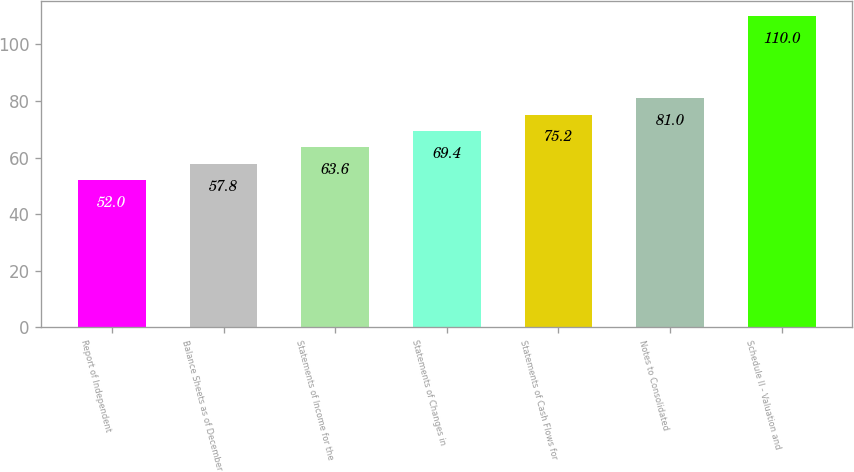<chart> <loc_0><loc_0><loc_500><loc_500><bar_chart><fcel>Report of Independent<fcel>Balance Sheets as of December<fcel>Statements of Income for the<fcel>Statements of Changes in<fcel>Statements of Cash Flows for<fcel>Notes to Consolidated<fcel>Schedule II - Valuation and<nl><fcel>52<fcel>57.8<fcel>63.6<fcel>69.4<fcel>75.2<fcel>81<fcel>110<nl></chart> 